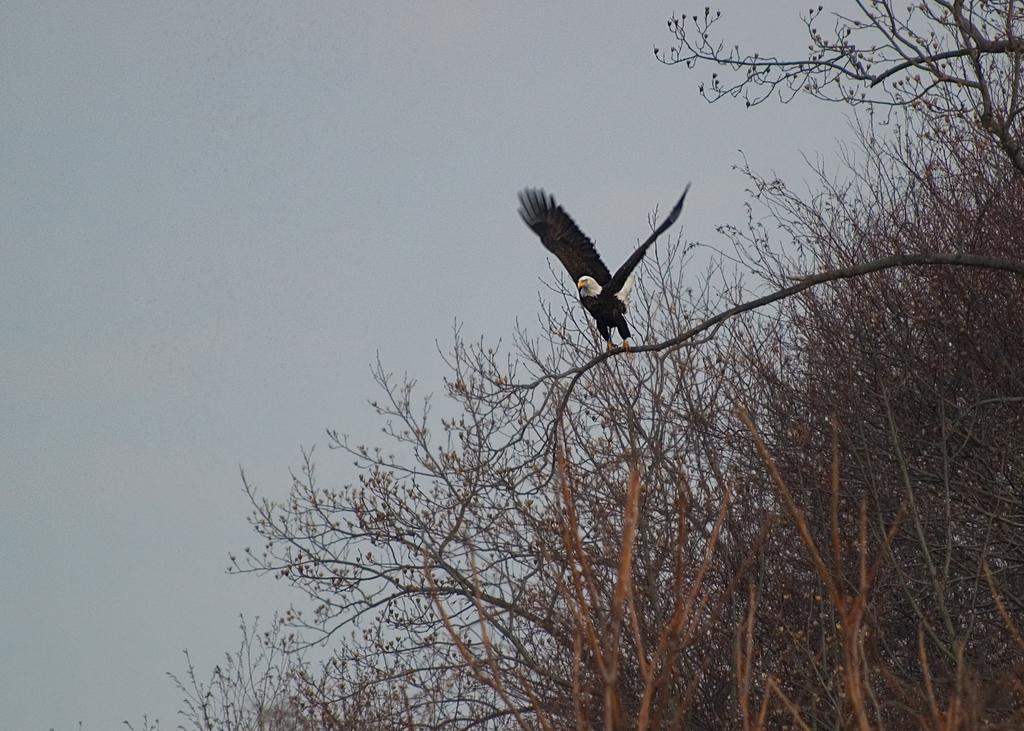In one or two sentences, can you explain what this image depicts? This picture is clicked outside. In the center we can see a black color eagle seems to be flying and we can see the trees and the sky. 